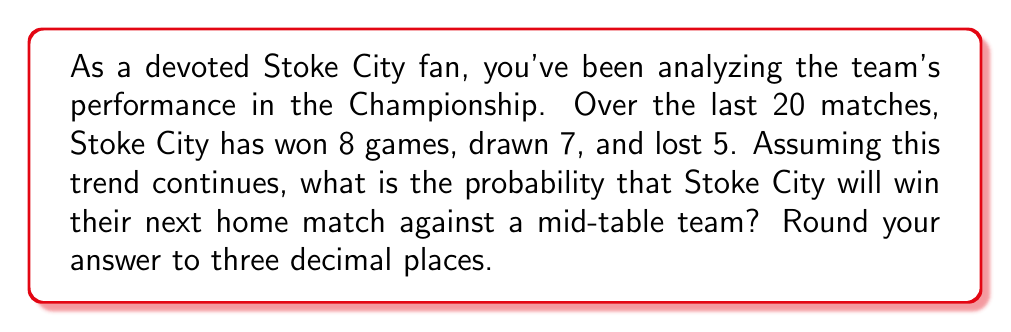What is the answer to this math problem? To solve this problem, we'll use the concept of relative frequency as an estimate of probability. Here's how we can approach it:

1. Calculate the total number of matches:
   $$ \text{Total matches} = 8 + 7 + 5 = 20 $$

2. Calculate the relative frequency of wins:
   $$ P(\text{win}) = \frac{\text{Number of wins}}{\text{Total matches}} = \frac{8}{20} = 0.4 $$

3. However, we need to consider that this is a home match. Home advantage typically increases a team's chances of winning. Let's assume a modest 10% increase in win probability for home games.

4. Adjust the probability for home advantage:
   $$ P(\text{home win}) = P(\text{win}) \times 1.1 = 0.4 \times 1.1 = 0.44 $$

5. Round the result to three decimal places:
   $$ P(\text{home win}) \approx 0.440 $$

This probability suggests that Stoke City has a slightly better than 44% chance of winning their next home match against a mid-table team, based on their recent performance and considering home advantage.
Answer: 0.440 